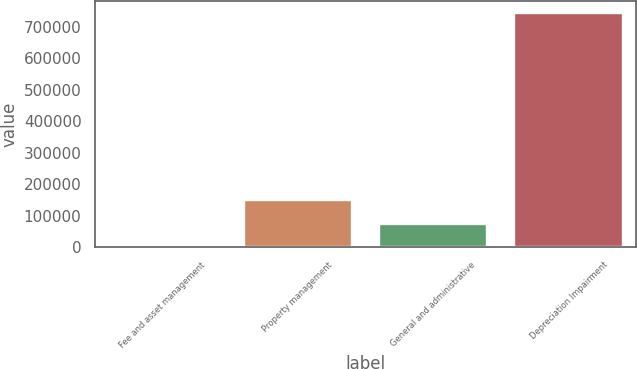Convert chart. <chart><loc_0><loc_0><loc_500><loc_500><bar_chart><fcel>Fee and asset management<fcel>Property management<fcel>General and administrative<fcel>Depreciation Impairment<nl><fcel>717<fcel>149323<fcel>75020.2<fcel>743749<nl></chart> 